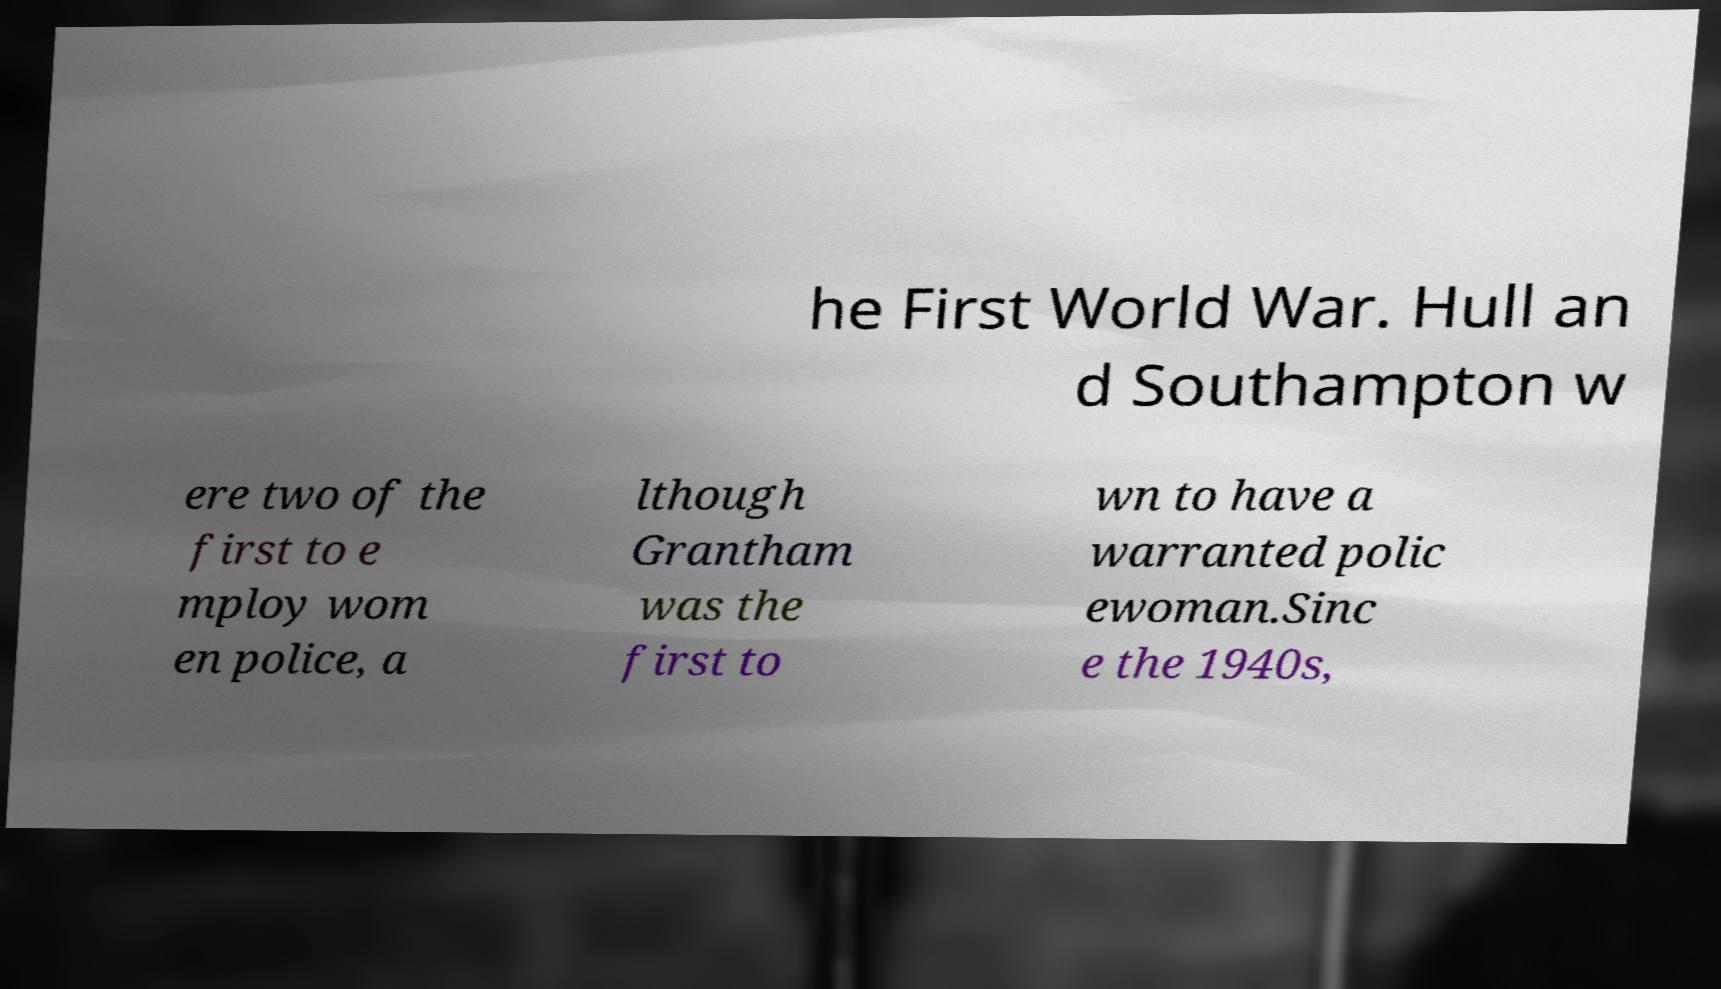Can you accurately transcribe the text from the provided image for me? he First World War. Hull an d Southampton w ere two of the first to e mploy wom en police, a lthough Grantham was the first to wn to have a warranted polic ewoman.Sinc e the 1940s, 